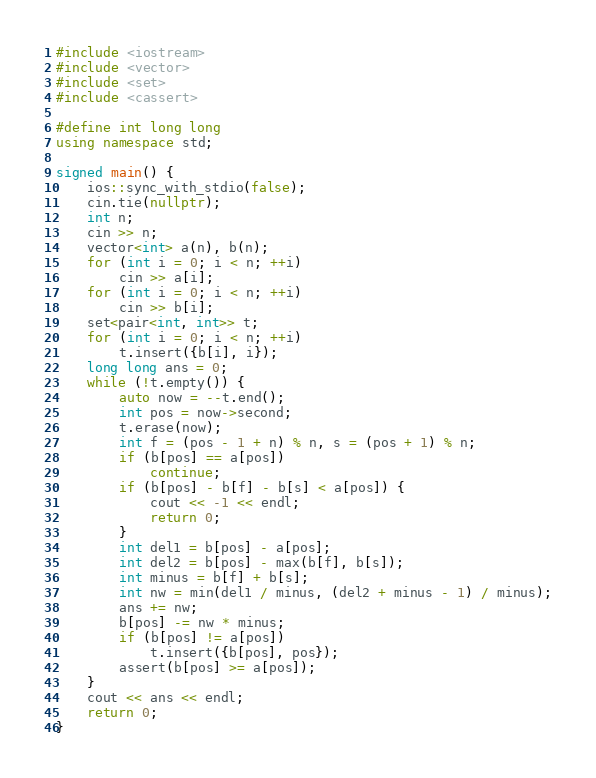Convert code to text. <code><loc_0><loc_0><loc_500><loc_500><_C++_>#include <iostream>
#include <vector>
#include <set>
#include <cassert>

#define int long long
using namespace std;

signed main() {
    ios::sync_with_stdio(false);
    cin.tie(nullptr);
    int n;
    cin >> n;
    vector<int> a(n), b(n);
    for (int i = 0; i < n; ++i)
        cin >> a[i];
    for (int i = 0; i < n; ++i)
        cin >> b[i];
    set<pair<int, int>> t;
    for (int i = 0; i < n; ++i)
        t.insert({b[i], i});
    long long ans = 0;
    while (!t.empty()) {
        auto now = --t.end();
        int pos = now->second;
        t.erase(now);
        int f = (pos - 1 + n) % n, s = (pos + 1) % n;
        if (b[pos] == a[pos])
            continue;
        if (b[pos] - b[f] - b[s] < a[pos]) {
            cout << -1 << endl;
            return 0;
        }
        int del1 = b[pos] - a[pos];
        int del2 = b[pos] - max(b[f], b[s]);
        int minus = b[f] + b[s];
        int nw = min(del1 / minus, (del2 + minus - 1) / minus);
        ans += nw;
        b[pos] -= nw * minus;
        if (b[pos] != a[pos])
            t.insert({b[pos], pos});
        assert(b[pos] >= a[pos]);
    }
    cout << ans << endl;
    return 0;
}
</code> 